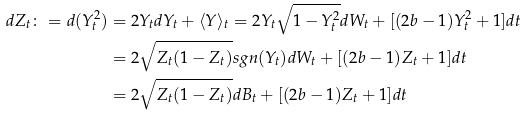Convert formula to latex. <formula><loc_0><loc_0><loc_500><loc_500>d Z _ { t } \colon = d ( Y _ { t } ^ { 2 } ) & = 2 Y _ { t } d Y _ { t } + \langle Y \rangle _ { t } = 2 Y _ { t } \sqrt { 1 - Y _ { t } ^ { 2 } } d W _ { t } + [ ( 2 b - 1 ) Y _ { t } ^ { 2 } + 1 ] d t \\ & = 2 \sqrt { Z _ { t } ( 1 - Z _ { t } ) } s g n ( Y _ { t } ) d W _ { t } + [ ( 2 b - 1 ) Z _ { t } + 1 ] d t \\ & = 2 \sqrt { Z _ { t } ( 1 - Z _ { t } ) } d B _ { t } + [ ( 2 b - 1 ) Z _ { t } + 1 ] d t</formula> 